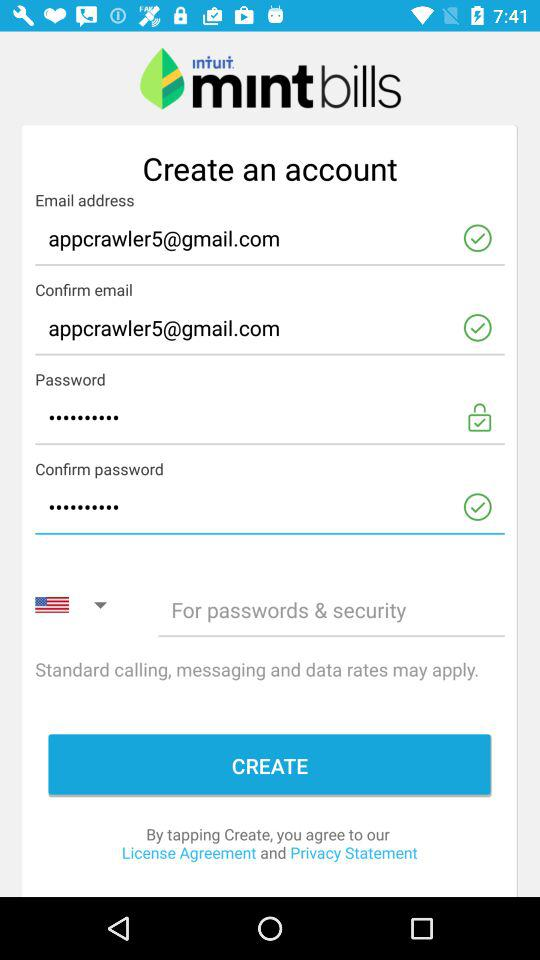What is the application name? The application name is "Mint Bills". 